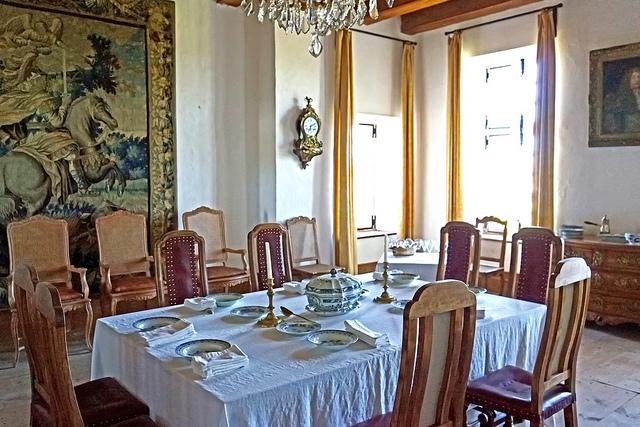Is the table set for dinner?
Be succinct. Yes. What color is the tablecloth?
Concise answer only. White. How many chairs have been put into place?
Write a very short answer. 7. 